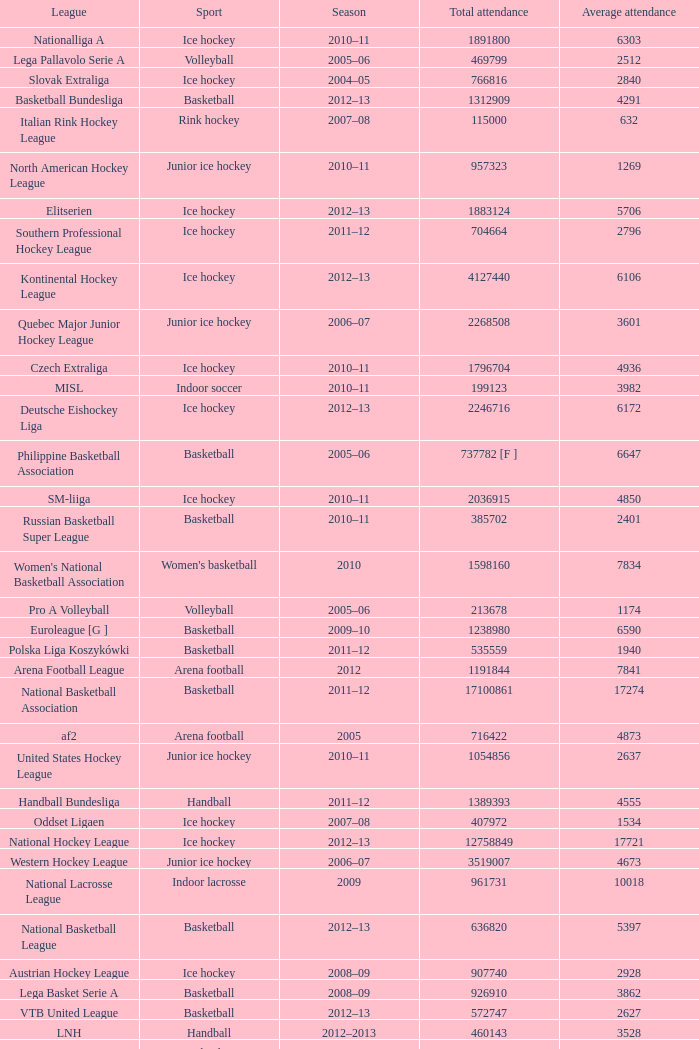What's the average attendance of the league with a total attendance of 2268508? 3601.0. 